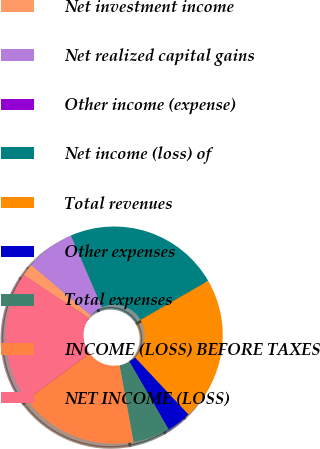Convert chart to OTSL. <chart><loc_0><loc_0><loc_500><loc_500><pie_chart><fcel>Net investment income<fcel>Net realized capital gains<fcel>Other income (expense)<fcel>Net income (loss) of<fcel>Total revenues<fcel>Other expenses<fcel>Total expenses<fcel>INCOME (LOSS) BEFORE TAXES<fcel>NET INCOME (LOSS)<nl><fcel>1.83%<fcel>7.29%<fcel>0.01%<fcel>23.17%<fcel>21.35%<fcel>3.65%<fcel>5.47%<fcel>17.71%<fcel>19.53%<nl></chart> 